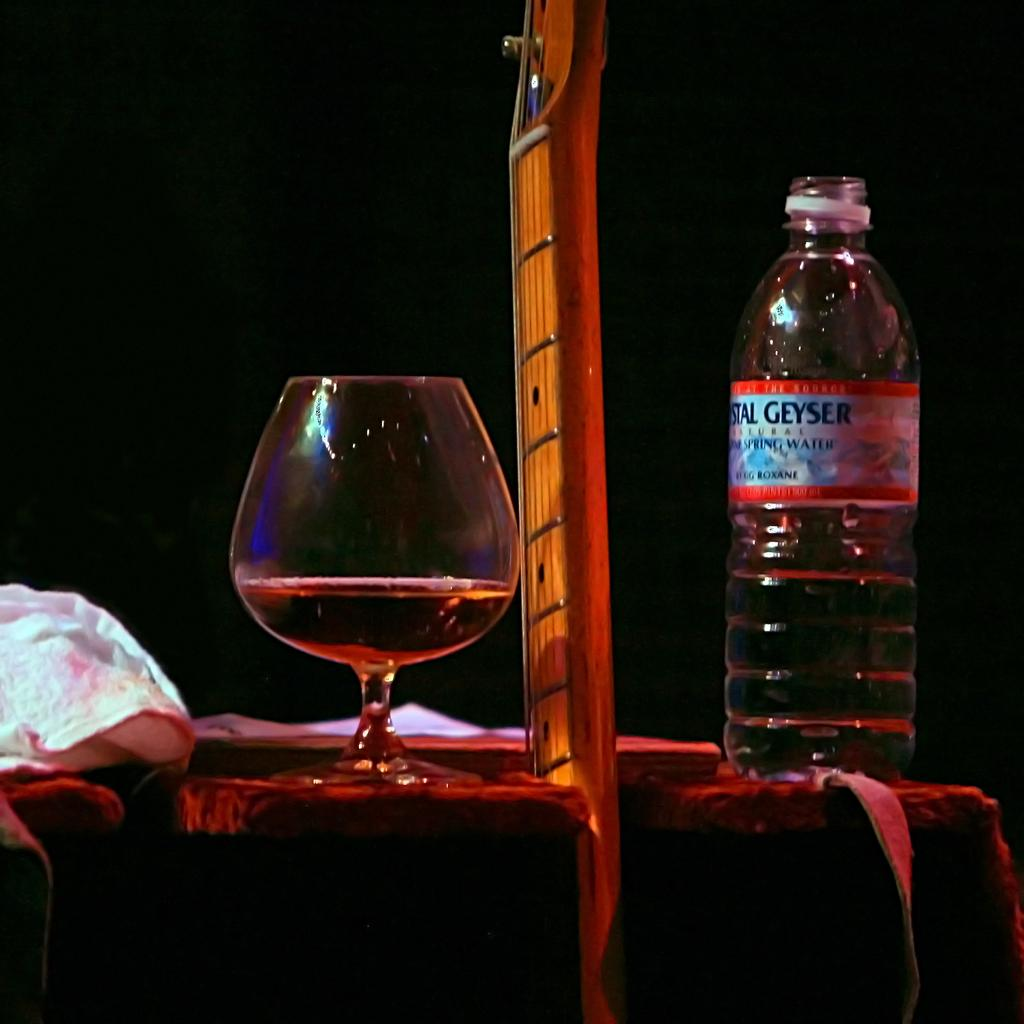What is present in the image that can hold a liquid? There is a bottle and a glass filled with a liquid in the image. Can you describe the contents of the glass? The glass is filled with a liquid, but the specific type of liquid is not mentioned in the facts. What else can be used to hold a liquid, besides the glass? The bottle can also be used to hold a liquid. What type of apparel is being worn by the record in the image? There is no record or apparel present in the image; it only features a bottle and a glass filled with a liquid. 